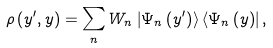Convert formula to latex. <formula><loc_0><loc_0><loc_500><loc_500>\rho \left ( y ^ { \prime } , y \right ) = \sum _ { n } W _ { n } \left | \Psi _ { n } \left ( y ^ { \prime } \right ) \right \rangle \left \langle \Psi _ { n } \left ( y \right ) \right | ,</formula> 